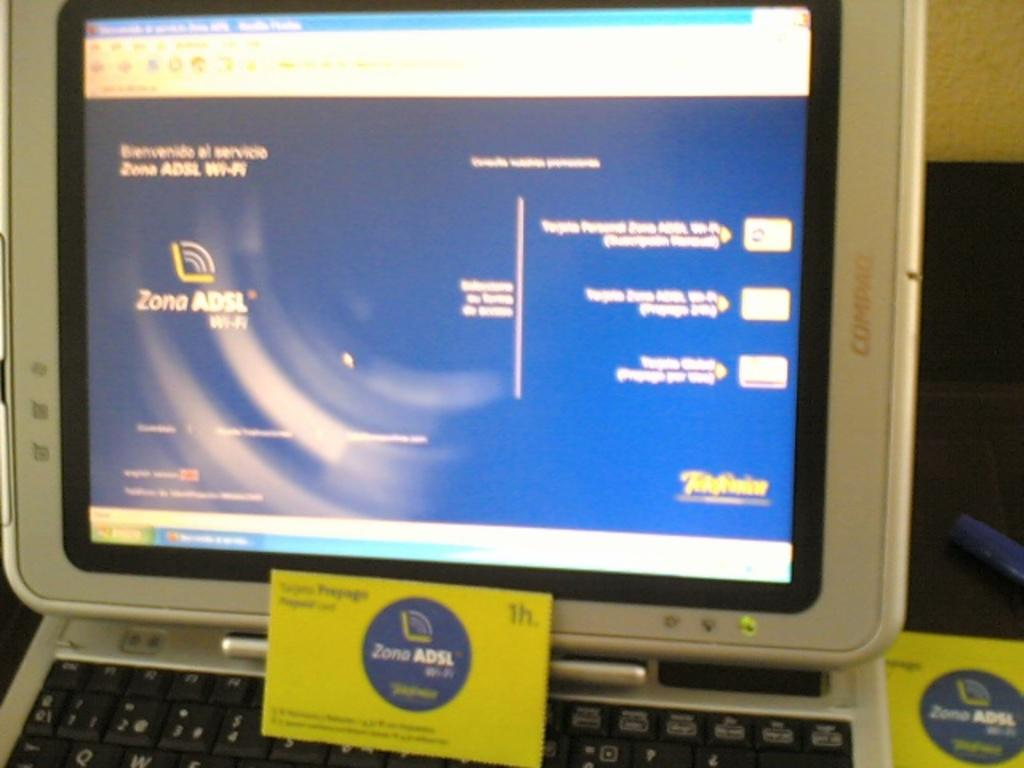<image>
Provide a brief description of the given image. A card that says "Zone ADSL" is propped up on a keyboard. 